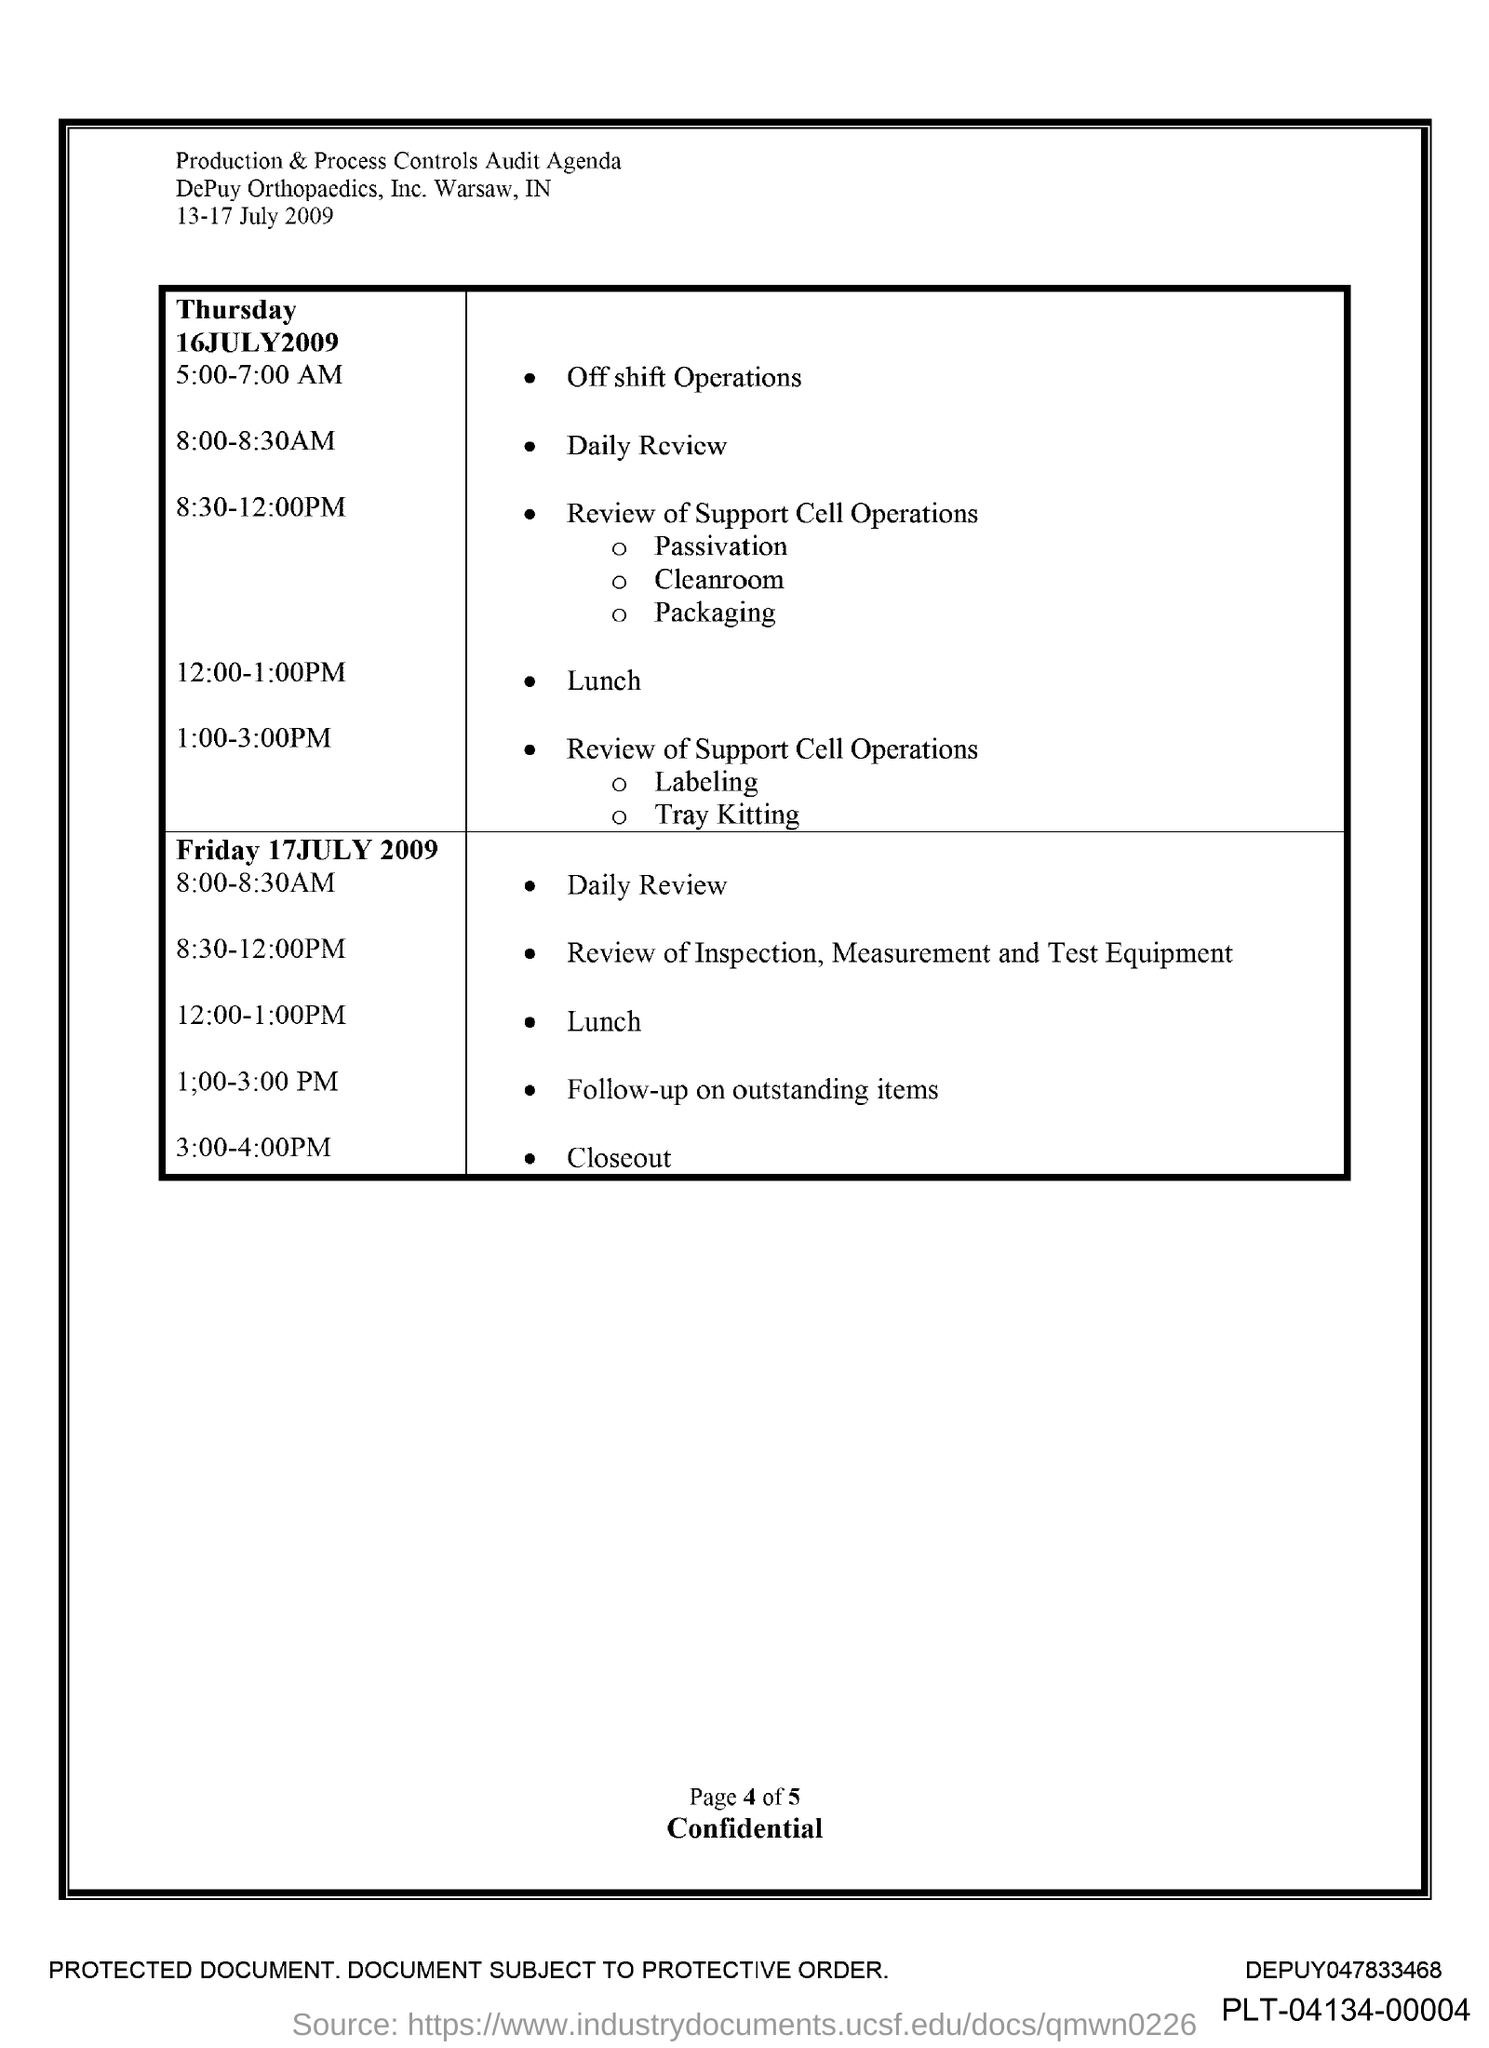Specify some key components in this picture. On Thursday, July 16th, 2009, the time for lunch was between 12:00 and 1:00 PM. The time for daily review on Thursday, July 16th, 2009, is 8:00-8:30 AM. 